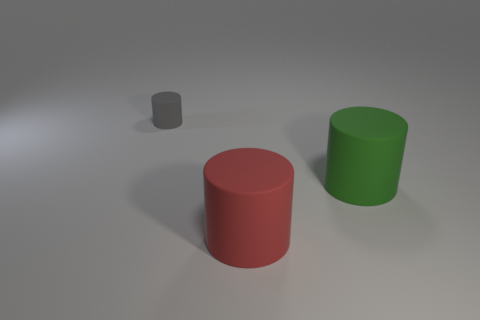There is a red matte thing; is its shape the same as the matte object that is left of the red rubber thing?
Offer a very short reply. Yes. Is there a tiny matte cylinder that has the same color as the small rubber object?
Your response must be concise. No. What number of cylinders are blue matte things or small matte things?
Give a very brief answer. 1. Is there a large cyan metallic thing that has the same shape as the red thing?
Offer a terse response. No. How many other things are the same color as the small cylinder?
Provide a short and direct response. 0. Are there fewer things to the right of the gray rubber thing than large brown metal objects?
Give a very brief answer. No. What number of tiny gray rubber things are there?
Provide a succinct answer. 1. What number of large red cylinders are the same material as the small gray thing?
Your response must be concise. 1. What number of objects are either rubber cylinders that are right of the tiny rubber object or gray cylinders?
Ensure brevity in your answer.  3. Are there fewer green things behind the gray matte object than large green cylinders to the right of the green object?
Your answer should be compact. No. 